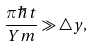<formula> <loc_0><loc_0><loc_500><loc_500>\frac { \pi \hbar { t } } { Y m } \gg \triangle y ,</formula> 